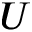<formula> <loc_0><loc_0><loc_500><loc_500>U</formula> 